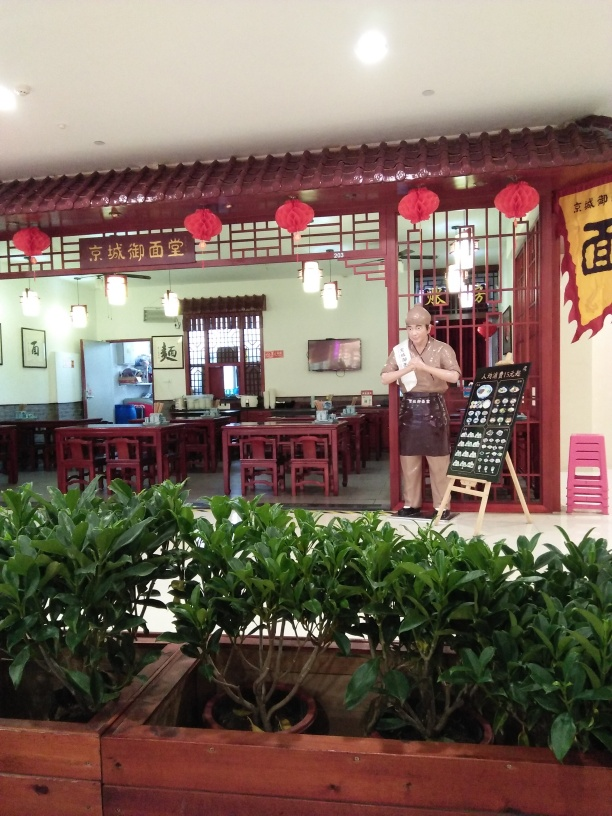Can you tell me more about the shop's atmosphere? The shop appears welcoming with its warm lighting, wooden furniture, and inviting open space. Red lanterns and Chinese calligraphy on the walls enhance the cultural atmosphere, suggesting a tranquil dining experience that celebrates traditional aesthetics. 